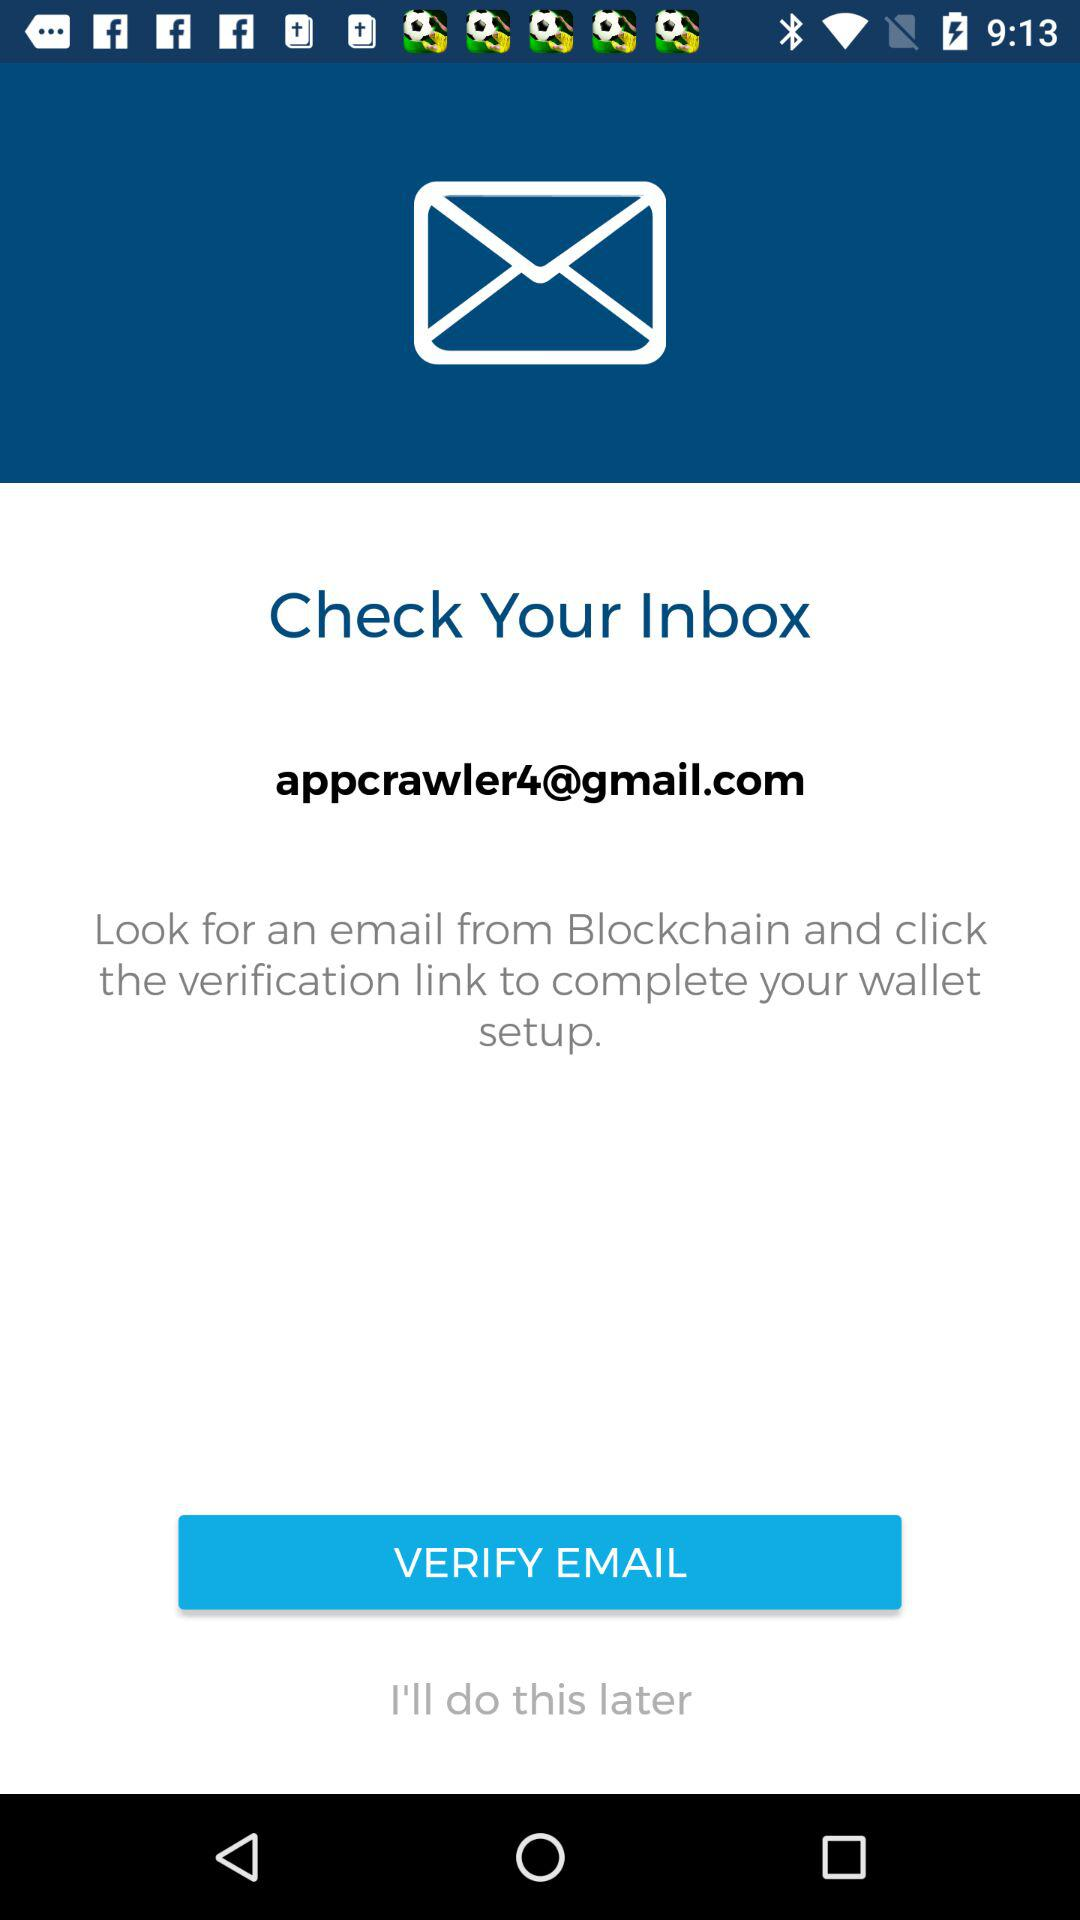What is the email address? The email address is appcrawler4@gmail.com. 